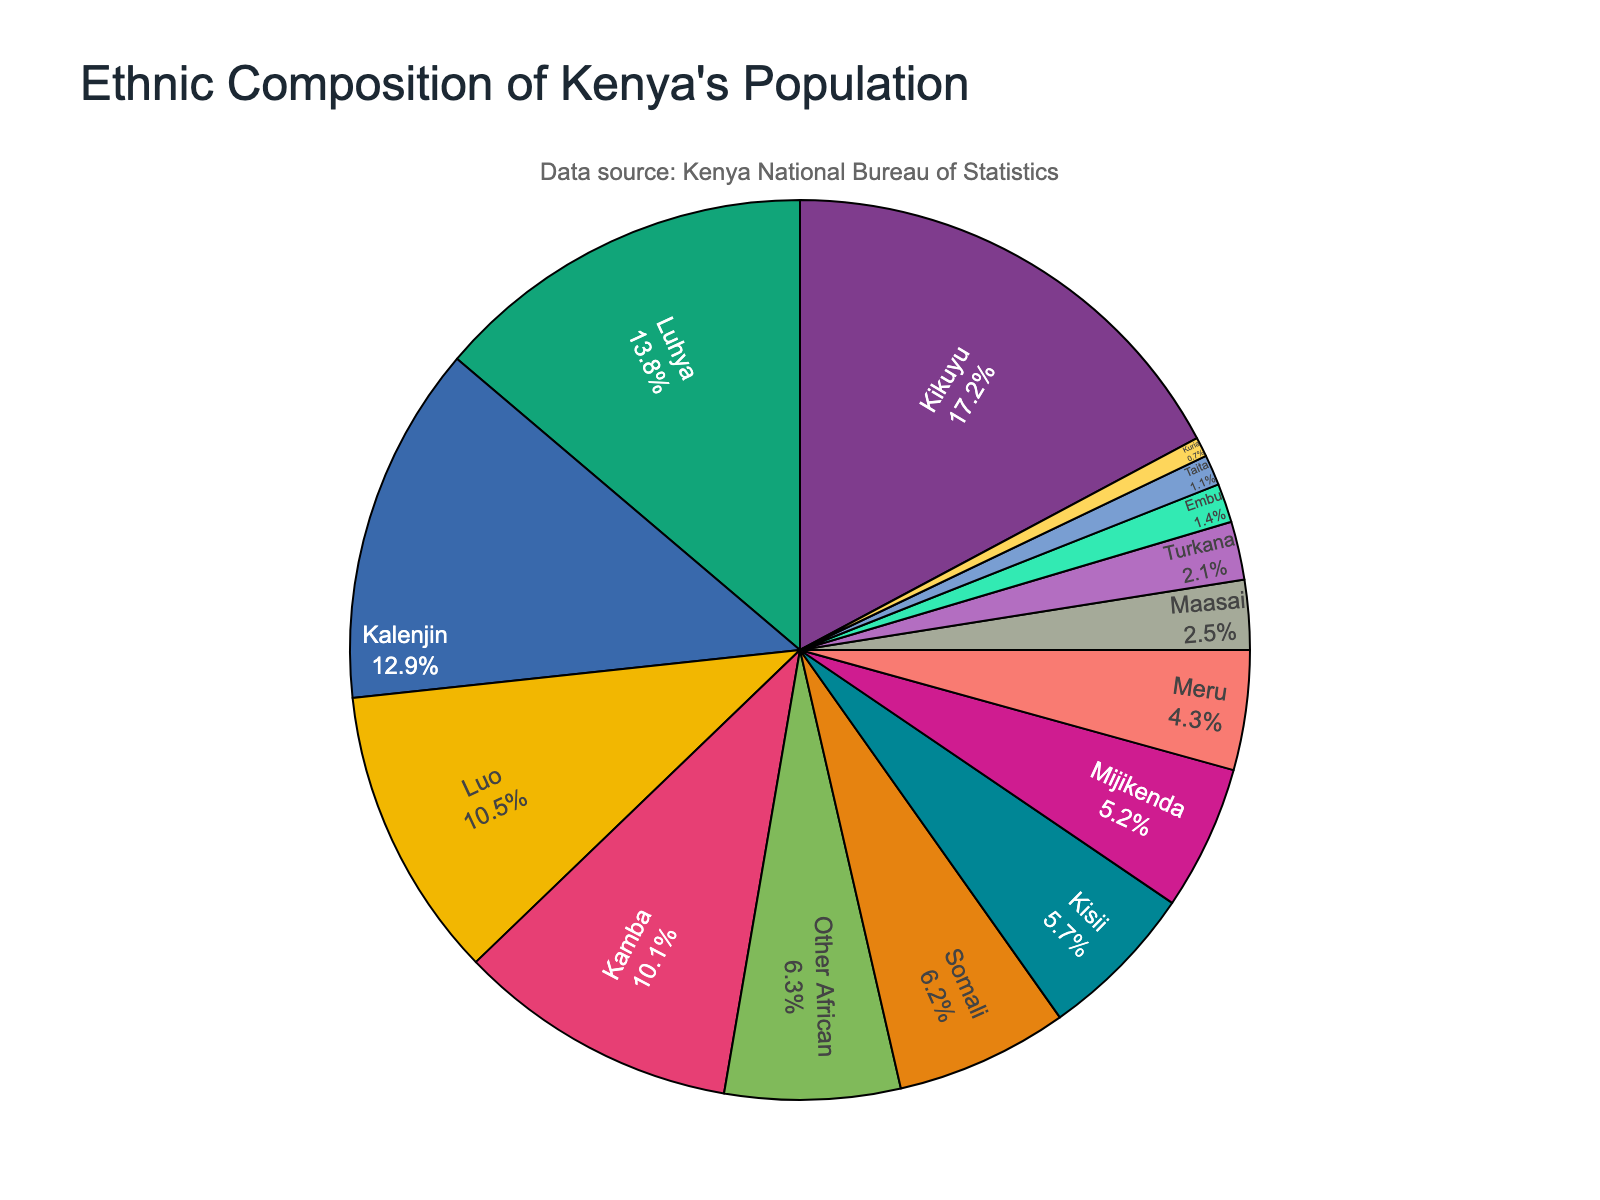Which ethnic group has the highest percentage in Kenya's population? Refer to the pie chart to see which segment is the largest. The Kikuyu segment is the largest.
Answer: Kikuyu Which ethnic group has the second highest percentage in Kenya's population? Look for the second largest segment of the pie chart. The Luhya segment is the second largest.
Answer: Luhya What is the combined percentage of the Kalenjin and Luo groups? Find the percentages of Kalenjin (12.9%) and Luo (10.5%), then add them: 12.9% + 10.5% = 23.4%.
Answer: 23.4% How much larger is the percentage of the Kikuyu group compared to the Maasai group? Subtract the Maasai percentage (2.5%) from the Kikuyu percentage (17.2%): 17.2% - 2.5% = 14.7%.
Answer: 14.7% Which two ethnic groups have the smallest percentages? Identify the smallest segments of the pie chart. The Kuria (0.7%) and Taita (1.1%) segments are the smallest.
Answer: Kuria and Taita Is the percentage of the Somali group greater than the combined percentage of the Maasai and Turkana groups? Somali percentage is 6.2%. Combine Maasai and Turkana percentages: 2.5% + 2.1% = 4.6%. Since 6.2% > 4.6%, yes.
Answer: Yes What is the median percentage value for the ethnic groups listed? Order the percentages and find the middle value. Ordered: 0.7%, 1.1%, 1.4%, 2.1%, 2.5%, 4.3%, 5.2%, 5.7%, 6.2%, 6.3%, 10.1%, 10.5%, 12.9%, 13.8%, 17.2%. The middle is 5.7%.
Answer: 5.7% Which ethnic group shares a similar population percentage to the 'Other African' category? Compare 'Other African' (6.3%) with other groups. The 'Somali' group has a similar percentage (6.2%).
Answer: Somali If you combine the percentages of Kikuyu, Luhya, and Kalenjin groups, what percentage do they make up of Kenya's population? Add the percentages: Kikuyu (17.2%), Luhya (13.8%), Kalenjin (12.9%). 17.2% + 13.8% + 12.9% = 43.9%.
Answer: 43.9% Which ethnic groups have a population percentage that falls below 3%? Refer to the pie chart to identify groups with percentages below 3%. Below 3%: Maasai (2.5%), Turkana (2.1%), Embu (1.4%), Taita (1.1%), Kuria (0.7%).
Answer: Maasai, Turkana, Embu, Taita, Kuria 